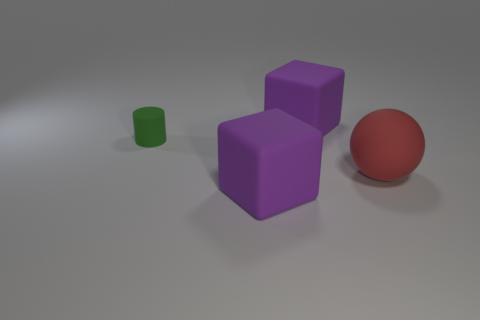Is there anything else that has the same shape as the small object?
Keep it short and to the point. No. Is there anything else that is the same size as the green cylinder?
Keep it short and to the point. No. Is the size of the thing that is behind the green cylinder the same as the big matte sphere?
Your response must be concise. Yes. There is a matte thing that is behind the sphere and right of the small green object; what is its shape?
Give a very brief answer. Cube. Is the number of big cubes that are in front of the red thing greater than the number of tiny yellow blocks?
Your answer should be very brief. Yes. There is a cylinder that is the same material as the red sphere; what is its size?
Your answer should be very brief. Small. What number of other large balls are the same color as the sphere?
Provide a short and direct response. 0. There is a big matte object in front of the red sphere; is it the same color as the small cylinder?
Give a very brief answer. No. Are there an equal number of red matte balls that are right of the ball and tiny objects to the left of the cylinder?
Provide a short and direct response. Yes. There is a big thing behind the small cylinder; what color is it?
Your response must be concise. Purple. 